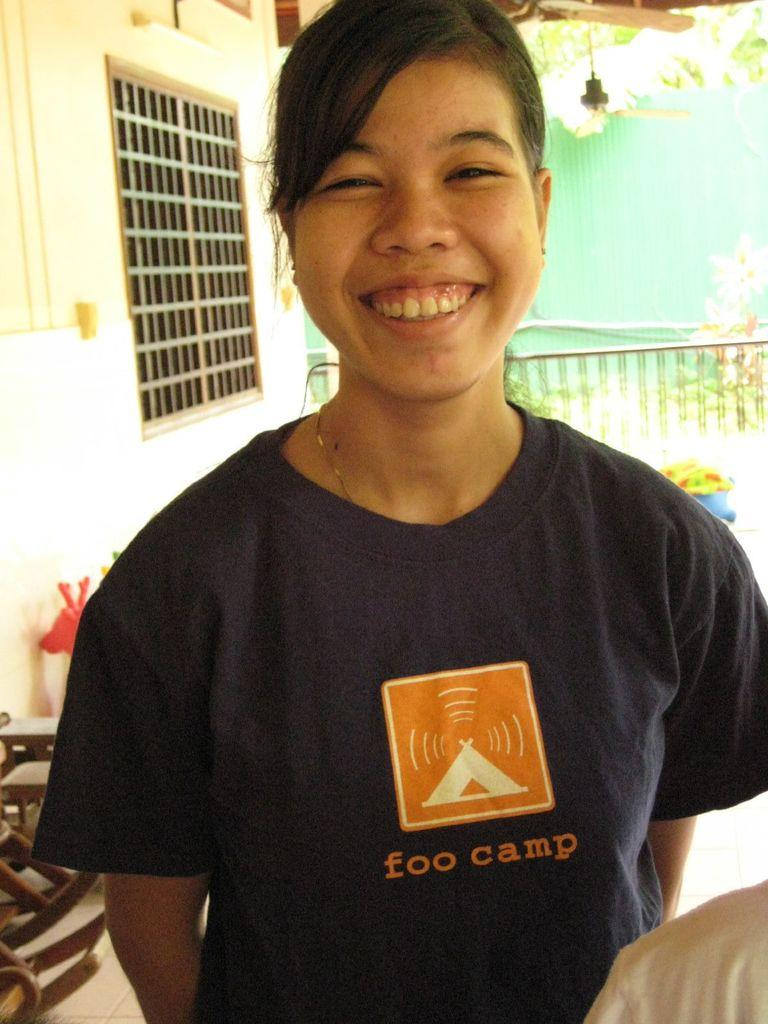Who is present in the image? There is a woman in the image. What is the woman's expression? The woman is smiling. What can be seen in the background of the image? There is a window, a fence, plants, a light source, and some objects visible in the background of the image. Can you tell me how many icicles are hanging from the fence in the image? There are no icicles present in the image; the fence is in the background, and there is no mention of icicles in the provided facts. 